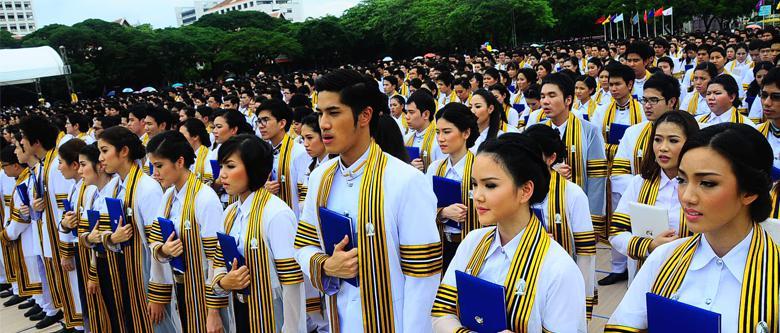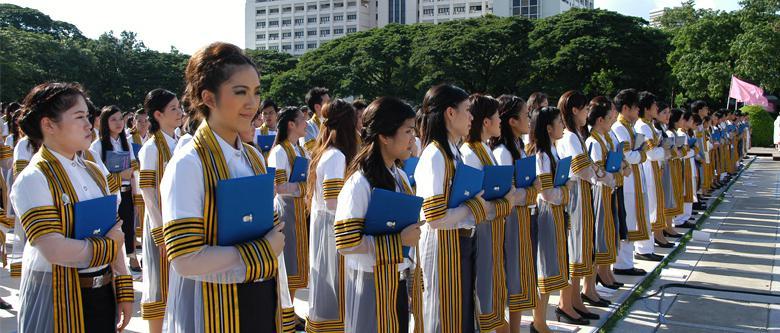The first image is the image on the left, the second image is the image on the right. Assess this claim about the two images: "One of the images features a young man standing in front of a building.". Correct or not? Answer yes or no. No. The first image is the image on the left, the second image is the image on the right. Assess this claim about the two images: "A large congregation of people are lined up in rows outside in at least one picture.". Correct or not? Answer yes or no. Yes. 